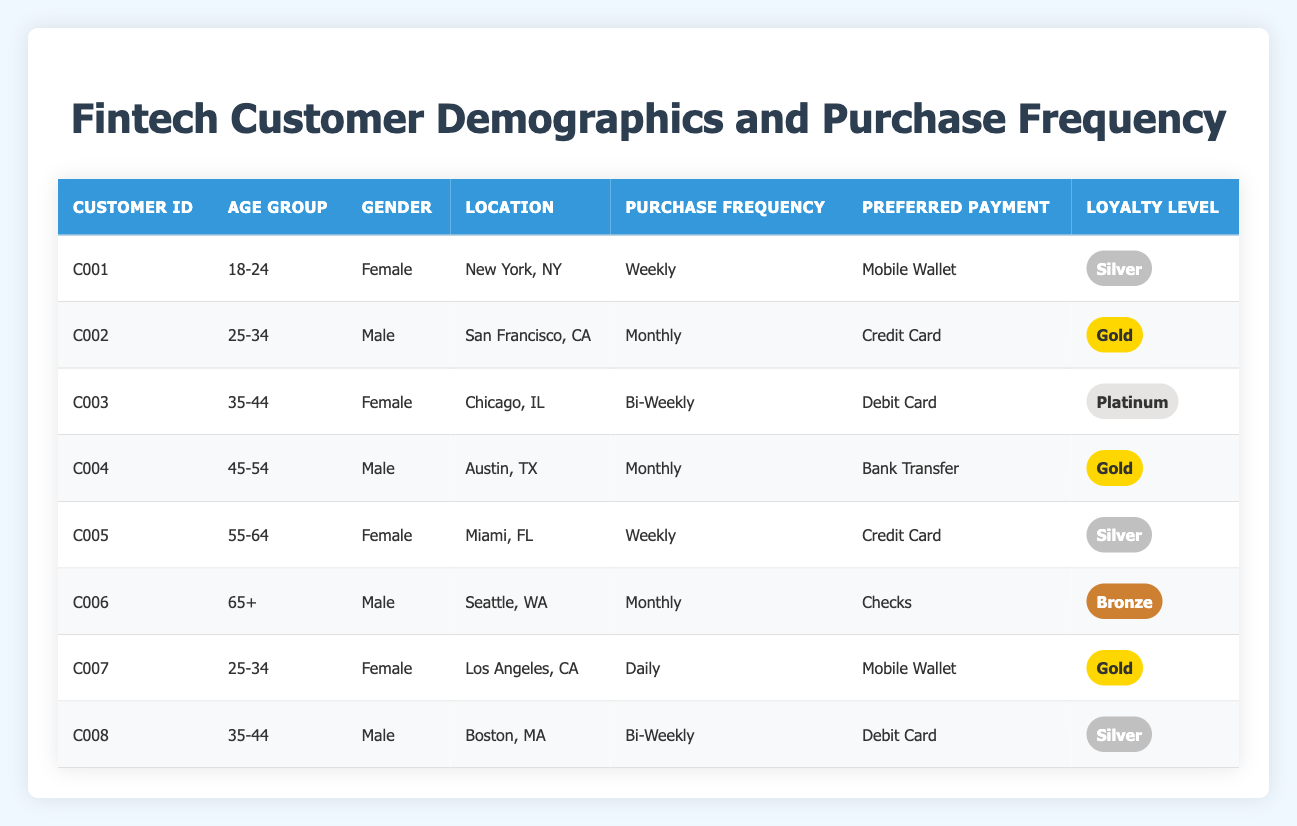What is the preferred payment method for customer C003? According to the table, customer C003 has a preferred payment method listed as Debit Card. This information is directly retrievable from the corresponding row for customer C003.
Answer: Debit Card How many customers have a loyalty level of Gold? By scanning the table, we count the occurrences of the Gold loyalty level. Customers C002, C007, and C004 each have the Gold loyalty level, resulting in a total of 3 customers.
Answer: 3 Which age group has the highest purchase frequency? Analyzing the purchase frequency, the following frequency levels are identified: Weekly (2 customers), Daily (1 customer), Bi-Weekly (2 customers), Monthly (3 customers). The maximum frequency is Weekly, shared by two customers, but no single age group has a higher frequency on its own, hence, we can consider the frequency that is highest.
Answer: Weekly Is there any customer whose preferred payment method is Checks? Looking through the table, customer C006 is noted for having Checks as the preferred payment method. This indicates that there is indeed at least one customer who uses Checks.
Answer: Yes What percentage of customers fall into the age group 25-34? To calculate the percentage, we first find how many customers are in the age group 25-34: C002 and C007, totaling 2 customers. The total number of customers is 8. The percentage is (2/8) * 100, giving us 25%.
Answer: 25% Are there any customers with a loyalty level of Bronze? Checking the loyalty levels in the table, customer C006 is categorized under Bronze, confirming the presence of at least one customer with a Bronze loyalty level.
Answer: Yes Which location has the most diverse payment methods? Based on the table, different locations present distinct payment methods: New York uses Mobile Wallet, San Francisco uses Credit Card, Chicago uses Debit Card, Austin uses Bank Transfer, Miami uses Credit Card, Seattle uses Checks, Los Angeles uses Mobile Wallet, and Boston uses Debit Card. All locations have unique payment methods, thus contributing to the diversity. Since no single location dominates, we can conclude locations collectively offer diversity.
Answer: Diverse methods across locations How many customers have a purchase frequency less than Weekly? Analyzing the purchase frequencies listed, Monthly (3 customers) and Bi-Weekly (2 customers) are below the Weekly threshold. Adding these together gives us 5 customers with purchase frequencies less than Weekly.
Answer: 5 